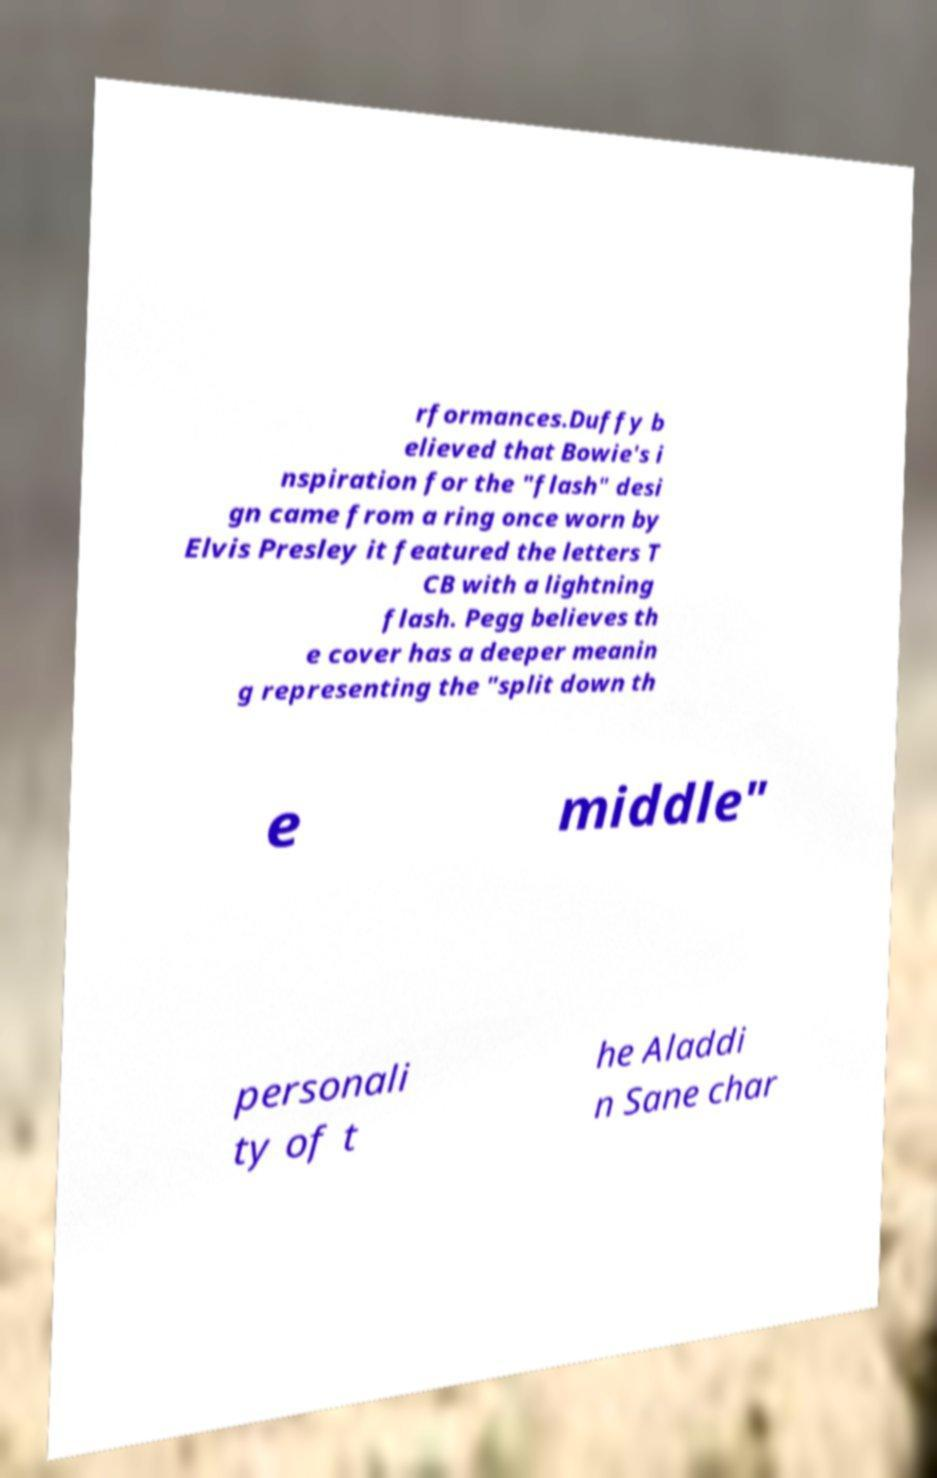Could you extract and type out the text from this image? rformances.Duffy b elieved that Bowie's i nspiration for the "flash" desi gn came from a ring once worn by Elvis Presley it featured the letters T CB with a lightning flash. Pegg believes th e cover has a deeper meanin g representing the "split down th e middle" personali ty of t he Aladdi n Sane char 